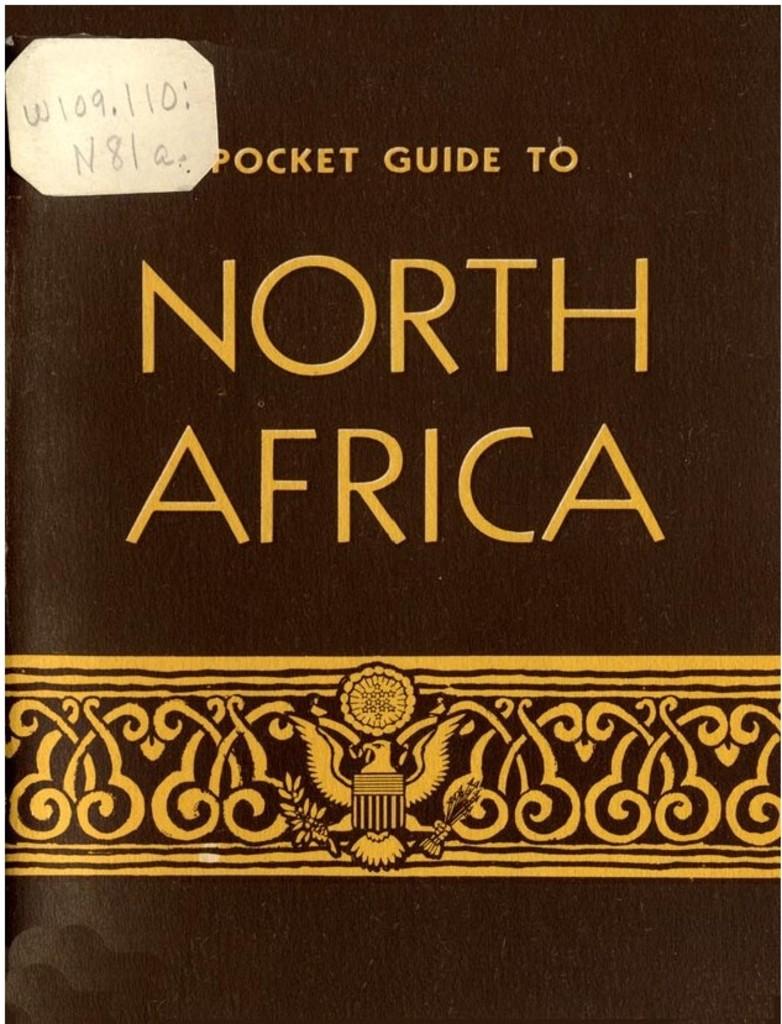What is this pocket guide?
Offer a very short reply. North africa. 